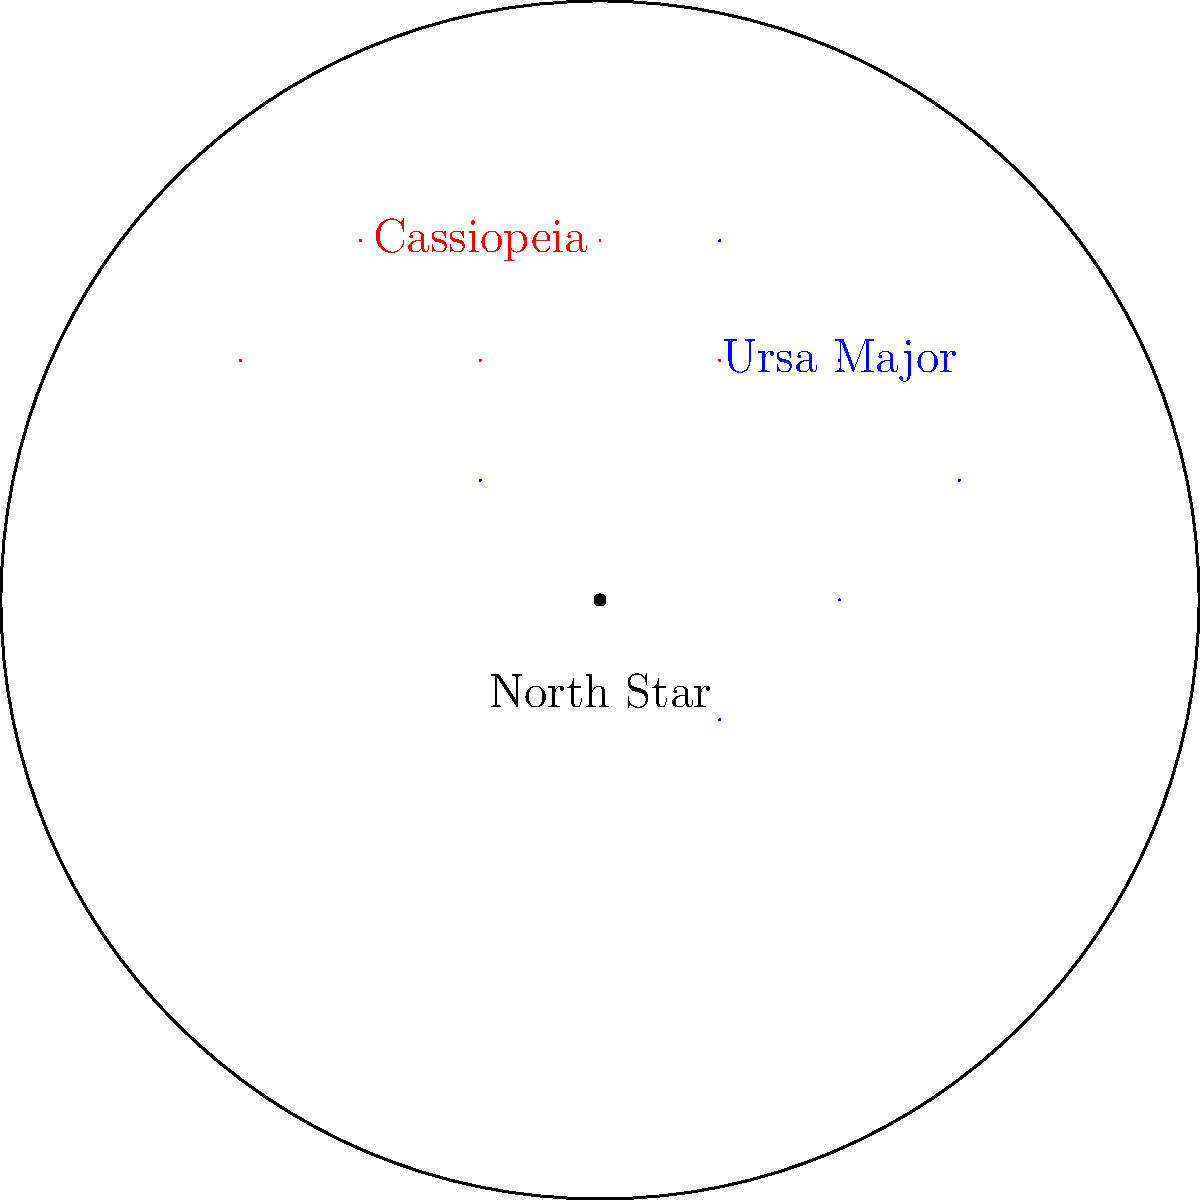As an actress who often films night scenes, you've become interested in astronomy. Using the star chart provided, which constellation would you use to locate the North Star quickly? To answer this question, let's follow these steps:

1. Examine the star chart: The chart shows two constellations - Ursa Major (in blue) and Cassiopeia (in red).

2. Understand the significance of the North Star: The North Star, also known as Polaris, is an important celestial object for navigation and orientation in the night sky.

3. Recognize the relationship between Ursa Major and the North Star:
   a. Ursa Major, also known as the Big Dipper, is one of the most recognizable constellations in the northern hemisphere.
   b. The two stars at the front edge of the Big Dipper's "bowl" point directly to the North Star.

4. Observe Cassiopeia's position:
   a. While Cassiopeia is also visible in the northern sky, it doesn't provide as direct a method for locating the North Star as Ursa Major does.

5. Consider the ease and speed of locating the North Star:
   a. Ursa Major's distinct shape makes it easier to spot quickly.
   b. The straight line from the two pointer stars in Ursa Major leads directly to the North Star, making it a faster method for locating it.

Therefore, Ursa Major (the Big Dipper) would be the more efficient constellation to use for quickly locating the North Star in the night sky.
Answer: Ursa Major 